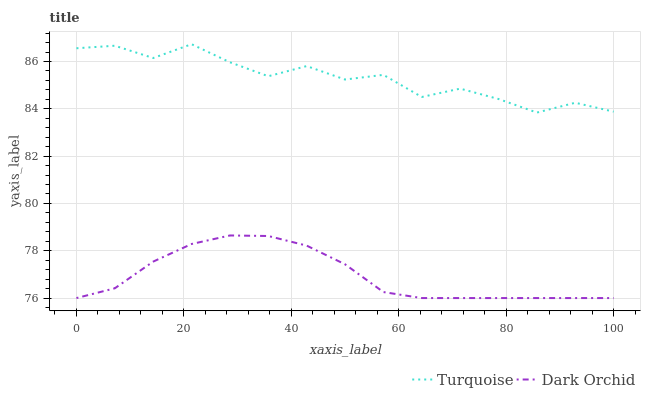Does Dark Orchid have the minimum area under the curve?
Answer yes or no. Yes. Does Turquoise have the maximum area under the curve?
Answer yes or no. Yes. Does Dark Orchid have the maximum area under the curve?
Answer yes or no. No. Is Dark Orchid the smoothest?
Answer yes or no. Yes. Is Turquoise the roughest?
Answer yes or no. Yes. Is Dark Orchid the roughest?
Answer yes or no. No. Does Dark Orchid have the lowest value?
Answer yes or no. Yes. Does Turquoise have the highest value?
Answer yes or no. Yes. Does Dark Orchid have the highest value?
Answer yes or no. No. Is Dark Orchid less than Turquoise?
Answer yes or no. Yes. Is Turquoise greater than Dark Orchid?
Answer yes or no. Yes. Does Dark Orchid intersect Turquoise?
Answer yes or no. No. 